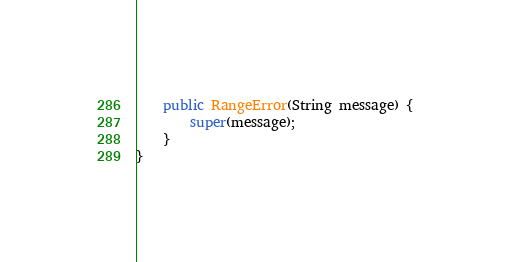<code> <loc_0><loc_0><loc_500><loc_500><_Java_>	public RangeError(String message) {
		super(message);
	}
}</code> 